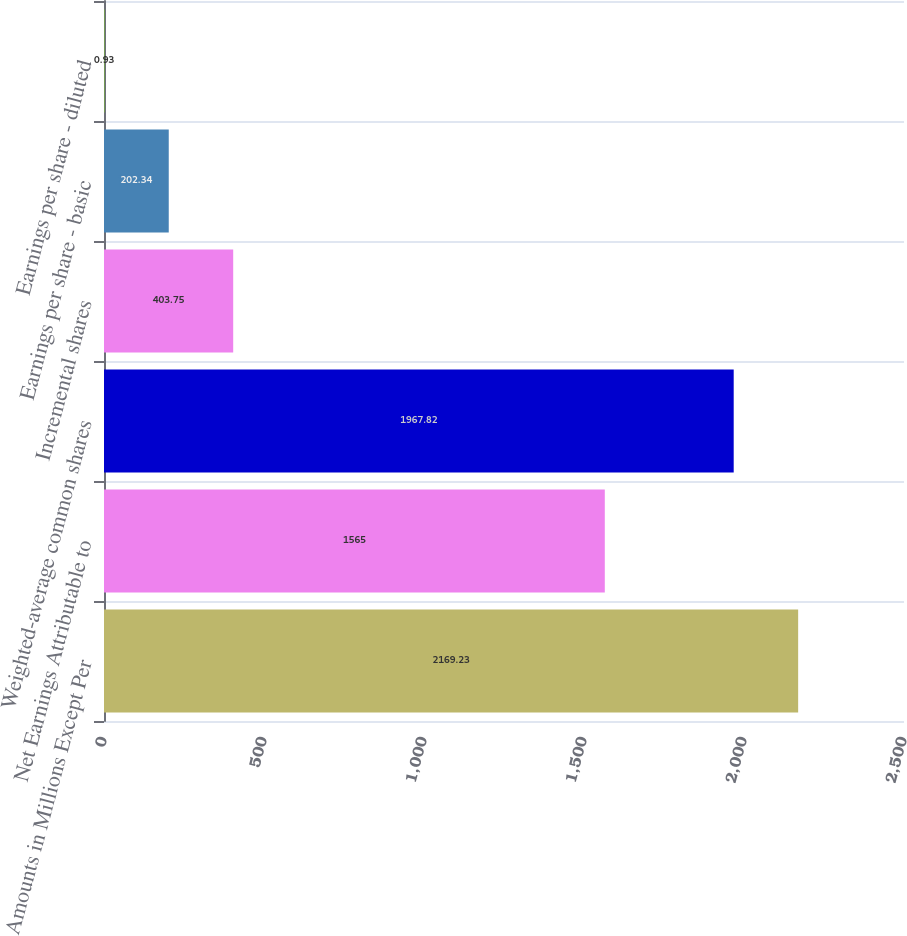Convert chart to OTSL. <chart><loc_0><loc_0><loc_500><loc_500><bar_chart><fcel>Amounts in Millions Except Per<fcel>Net Earnings Attributable to<fcel>Weighted-average common shares<fcel>Incremental shares<fcel>Earnings per share - basic<fcel>Earnings per share - diluted<nl><fcel>2169.23<fcel>1565<fcel>1967.82<fcel>403.75<fcel>202.34<fcel>0.93<nl></chart> 